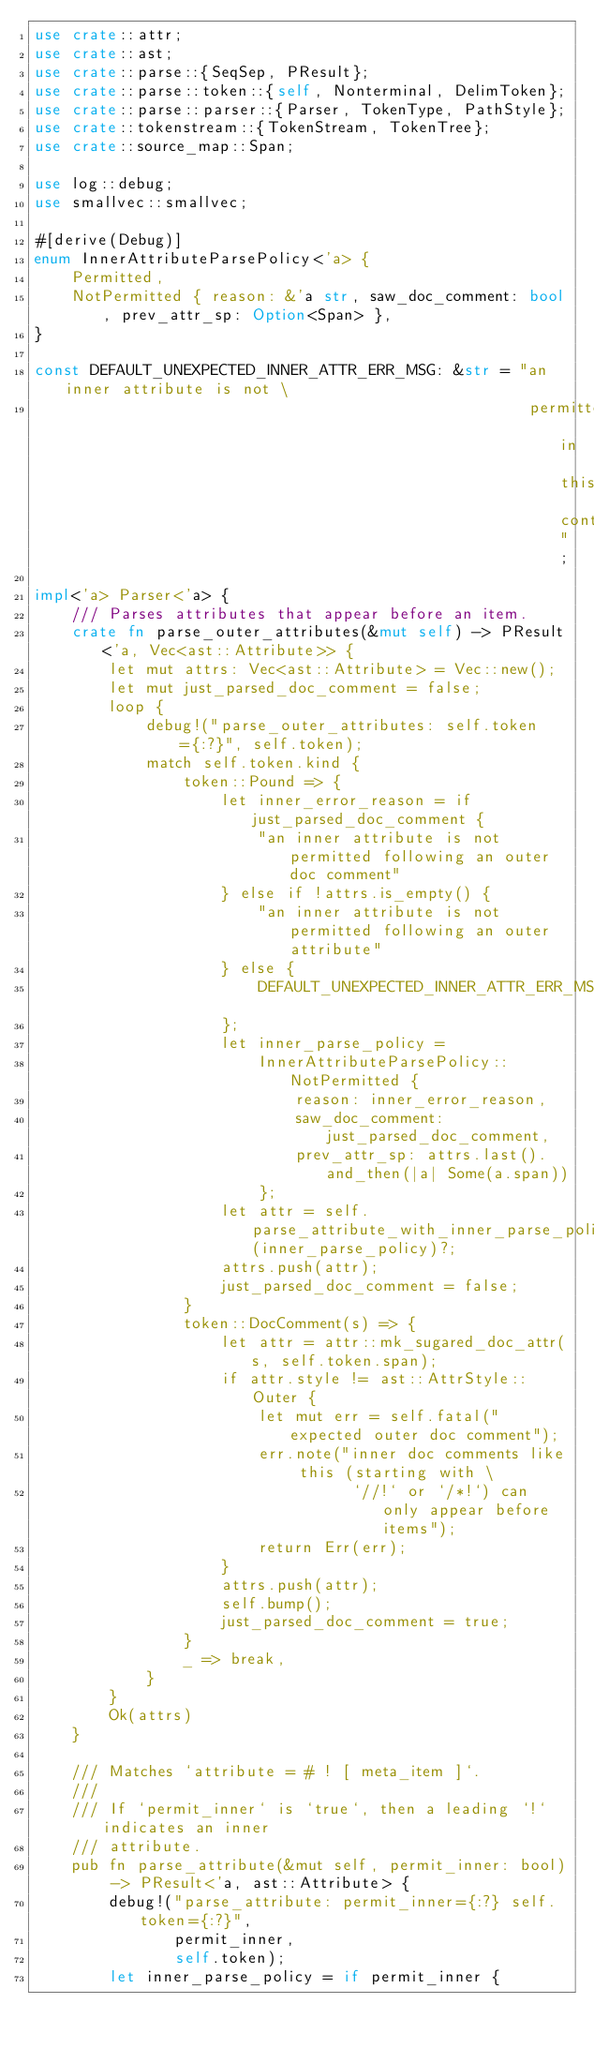Convert code to text. <code><loc_0><loc_0><loc_500><loc_500><_Rust_>use crate::attr;
use crate::ast;
use crate::parse::{SeqSep, PResult};
use crate::parse::token::{self, Nonterminal, DelimToken};
use crate::parse::parser::{Parser, TokenType, PathStyle};
use crate::tokenstream::{TokenStream, TokenTree};
use crate::source_map::Span;

use log::debug;
use smallvec::smallvec;

#[derive(Debug)]
enum InnerAttributeParsePolicy<'a> {
    Permitted,
    NotPermitted { reason: &'a str, saw_doc_comment: bool, prev_attr_sp: Option<Span> },
}

const DEFAULT_UNEXPECTED_INNER_ATTR_ERR_MSG: &str = "an inner attribute is not \
                                                     permitted in this context";

impl<'a> Parser<'a> {
    /// Parses attributes that appear before an item.
    crate fn parse_outer_attributes(&mut self) -> PResult<'a, Vec<ast::Attribute>> {
        let mut attrs: Vec<ast::Attribute> = Vec::new();
        let mut just_parsed_doc_comment = false;
        loop {
            debug!("parse_outer_attributes: self.token={:?}", self.token);
            match self.token.kind {
                token::Pound => {
                    let inner_error_reason = if just_parsed_doc_comment {
                        "an inner attribute is not permitted following an outer doc comment"
                    } else if !attrs.is_empty() {
                        "an inner attribute is not permitted following an outer attribute"
                    } else {
                        DEFAULT_UNEXPECTED_INNER_ATTR_ERR_MSG
                    };
                    let inner_parse_policy =
                        InnerAttributeParsePolicy::NotPermitted {
                            reason: inner_error_reason,
                            saw_doc_comment: just_parsed_doc_comment,
                            prev_attr_sp: attrs.last().and_then(|a| Some(a.span))
                        };
                    let attr = self.parse_attribute_with_inner_parse_policy(inner_parse_policy)?;
                    attrs.push(attr);
                    just_parsed_doc_comment = false;
                }
                token::DocComment(s) => {
                    let attr = attr::mk_sugared_doc_attr(s, self.token.span);
                    if attr.style != ast::AttrStyle::Outer {
                        let mut err = self.fatal("expected outer doc comment");
                        err.note("inner doc comments like this (starting with \
                                  `//!` or `/*!`) can only appear before items");
                        return Err(err);
                    }
                    attrs.push(attr);
                    self.bump();
                    just_parsed_doc_comment = true;
                }
                _ => break,
            }
        }
        Ok(attrs)
    }

    /// Matches `attribute = # ! [ meta_item ]`.
    ///
    /// If `permit_inner` is `true`, then a leading `!` indicates an inner
    /// attribute.
    pub fn parse_attribute(&mut self, permit_inner: bool) -> PResult<'a, ast::Attribute> {
        debug!("parse_attribute: permit_inner={:?} self.token={:?}",
               permit_inner,
               self.token);
        let inner_parse_policy = if permit_inner {</code> 